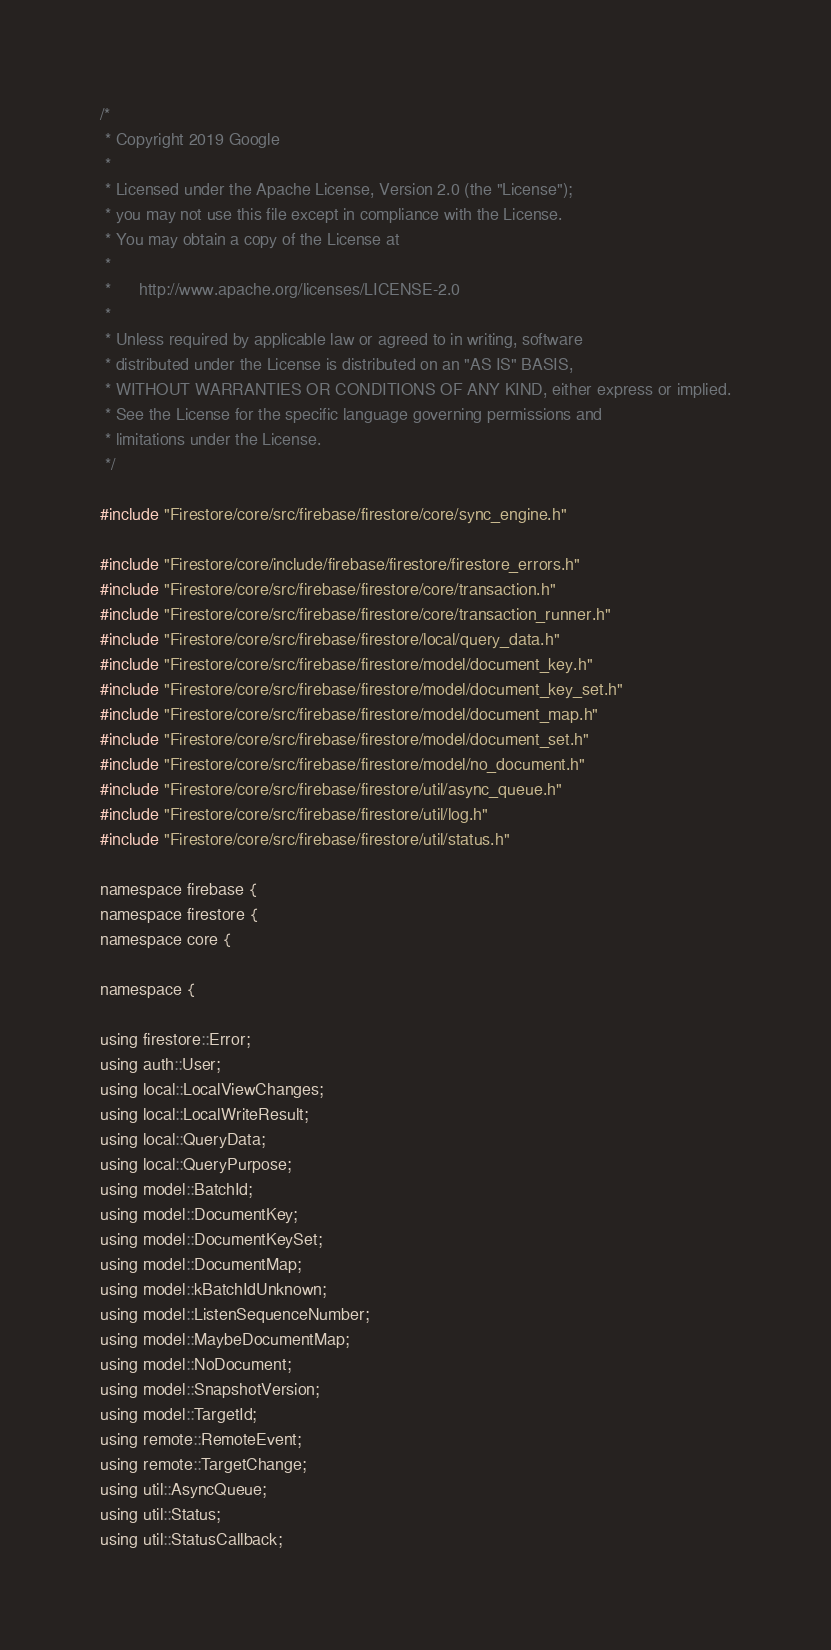Convert code to text. <code><loc_0><loc_0><loc_500><loc_500><_ObjectiveC_>/*
 * Copyright 2019 Google
 *
 * Licensed under the Apache License, Version 2.0 (the "License");
 * you may not use this file except in compliance with the License.
 * You may obtain a copy of the License at
 *
 *      http://www.apache.org/licenses/LICENSE-2.0
 *
 * Unless required by applicable law or agreed to in writing, software
 * distributed under the License is distributed on an "AS IS" BASIS,
 * WITHOUT WARRANTIES OR CONDITIONS OF ANY KIND, either express or implied.
 * See the License for the specific language governing permissions and
 * limitations under the License.
 */

#include "Firestore/core/src/firebase/firestore/core/sync_engine.h"

#include "Firestore/core/include/firebase/firestore/firestore_errors.h"
#include "Firestore/core/src/firebase/firestore/core/transaction.h"
#include "Firestore/core/src/firebase/firestore/core/transaction_runner.h"
#include "Firestore/core/src/firebase/firestore/local/query_data.h"
#include "Firestore/core/src/firebase/firestore/model/document_key.h"
#include "Firestore/core/src/firebase/firestore/model/document_key_set.h"
#include "Firestore/core/src/firebase/firestore/model/document_map.h"
#include "Firestore/core/src/firebase/firestore/model/document_set.h"
#include "Firestore/core/src/firebase/firestore/model/no_document.h"
#include "Firestore/core/src/firebase/firestore/util/async_queue.h"
#include "Firestore/core/src/firebase/firestore/util/log.h"
#include "Firestore/core/src/firebase/firestore/util/status.h"

namespace firebase {
namespace firestore {
namespace core {

namespace {

using firestore::Error;
using auth::User;
using local::LocalViewChanges;
using local::LocalWriteResult;
using local::QueryData;
using local::QueryPurpose;
using model::BatchId;
using model::DocumentKey;
using model::DocumentKeySet;
using model::DocumentMap;
using model::kBatchIdUnknown;
using model::ListenSequenceNumber;
using model::MaybeDocumentMap;
using model::NoDocument;
using model::SnapshotVersion;
using model::TargetId;
using remote::RemoteEvent;
using remote::TargetChange;
using util::AsyncQueue;
using util::Status;
using util::StatusCallback;
</code> 